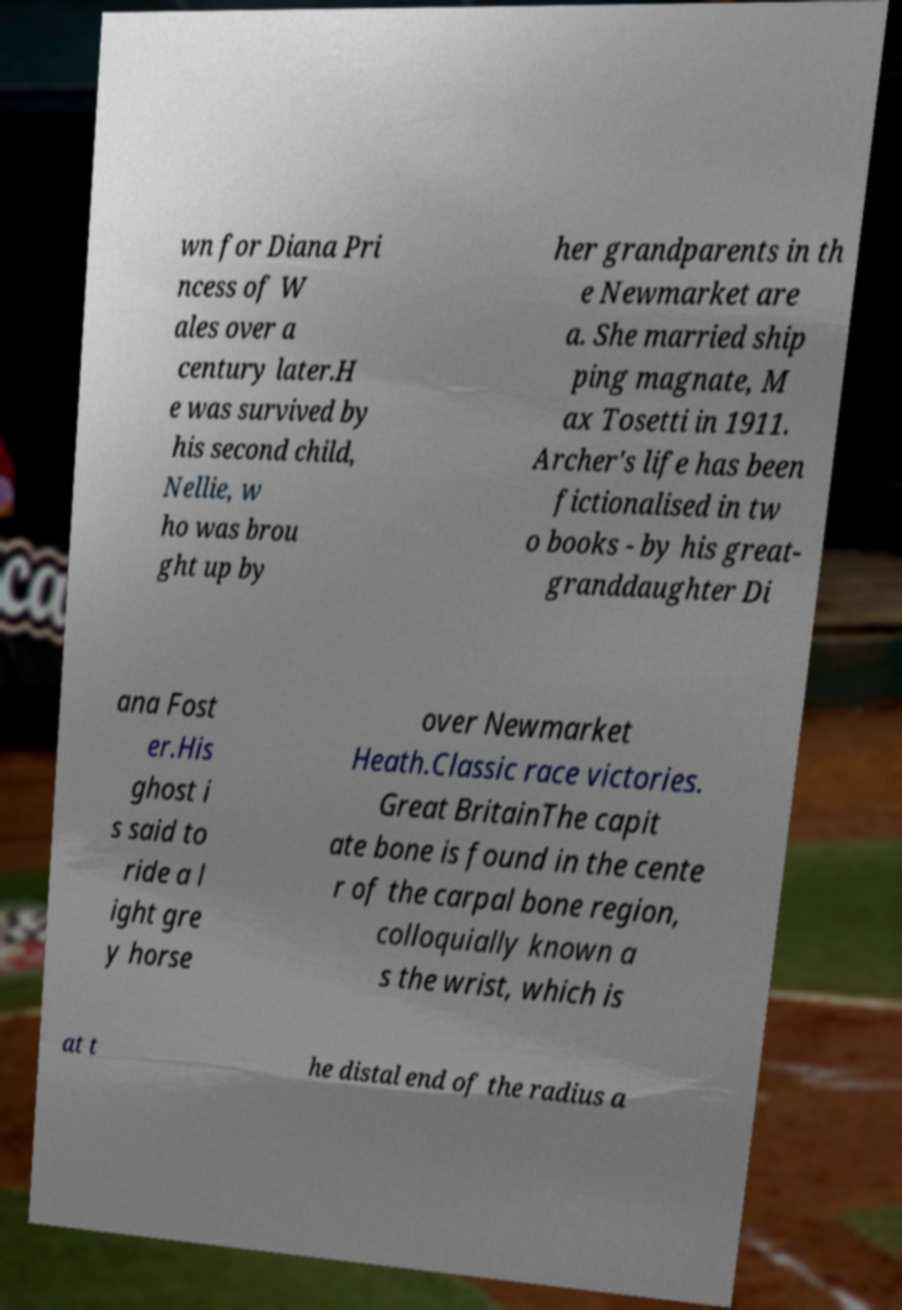For documentation purposes, I need the text within this image transcribed. Could you provide that? wn for Diana Pri ncess of W ales over a century later.H e was survived by his second child, Nellie, w ho was brou ght up by her grandparents in th e Newmarket are a. She married ship ping magnate, M ax Tosetti in 1911. Archer's life has been fictionalised in tw o books - by his great- granddaughter Di ana Fost er.His ghost i s said to ride a l ight gre y horse over Newmarket Heath.Classic race victories. Great BritainThe capit ate bone is found in the cente r of the carpal bone region, colloquially known a s the wrist, which is at t he distal end of the radius a 